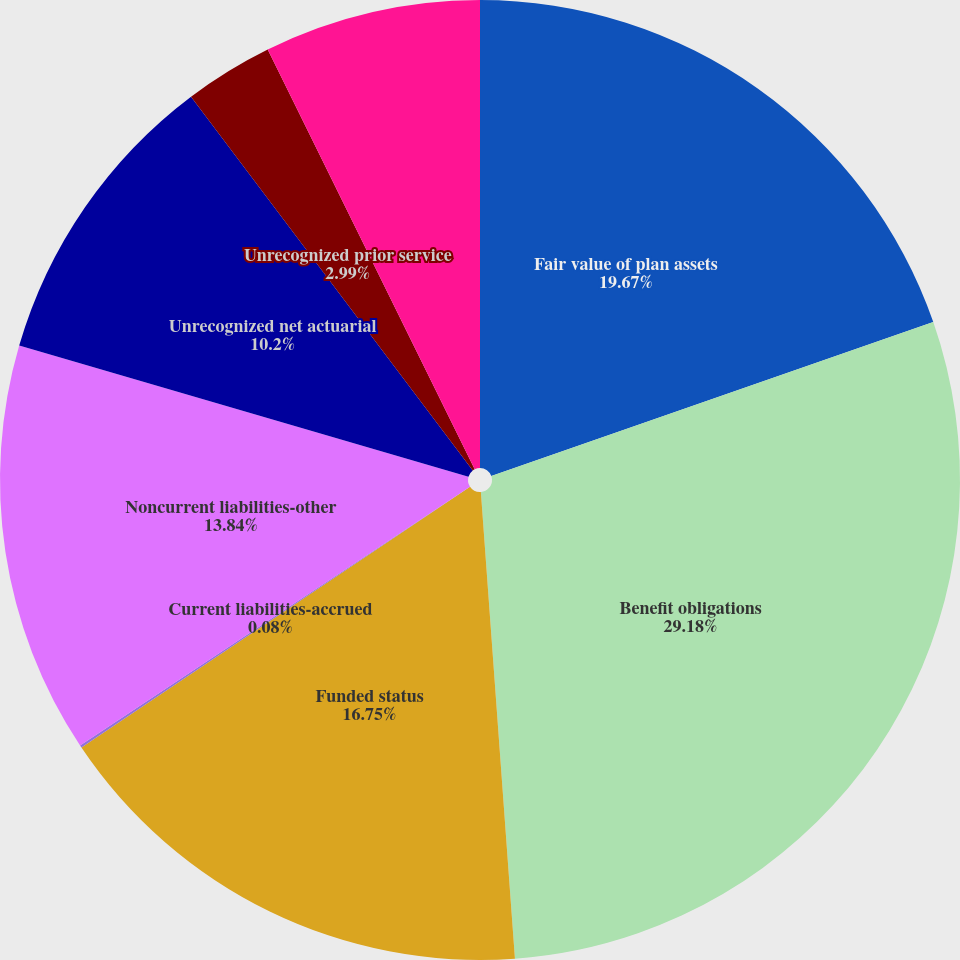<chart> <loc_0><loc_0><loc_500><loc_500><pie_chart><fcel>Fair value of plan assets<fcel>Benefit obligations<fcel>Funded status<fcel>Current liabilities-accrued<fcel>Noncurrent liabilities-other<fcel>Unrecognized net actuarial<fcel>Unrecognized prior service<fcel>Total<nl><fcel>19.66%<fcel>29.17%<fcel>16.75%<fcel>0.08%<fcel>13.84%<fcel>10.2%<fcel>2.99%<fcel>7.29%<nl></chart> 